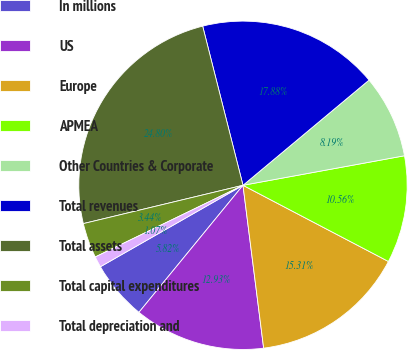<chart> <loc_0><loc_0><loc_500><loc_500><pie_chart><fcel>In millions<fcel>US<fcel>Europe<fcel>APMEA<fcel>Other Countries & Corporate<fcel>Total revenues<fcel>Total assets<fcel>Total capital expenditures<fcel>Total depreciation and<nl><fcel>5.82%<fcel>12.93%<fcel>15.31%<fcel>10.56%<fcel>8.19%<fcel>17.88%<fcel>24.8%<fcel>3.44%<fcel>1.07%<nl></chart> 